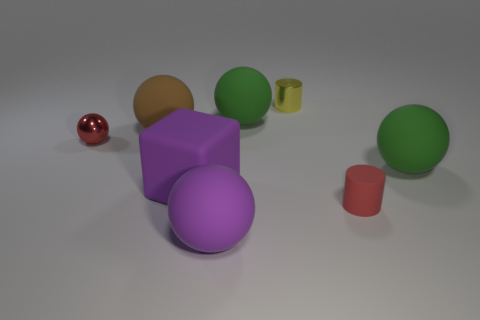Do the tiny red thing that is on the left side of the tiny matte cylinder and the metallic object behind the brown object have the same shape?
Offer a terse response. No. What shape is the red rubber object that is the same size as the yellow metallic object?
Provide a short and direct response. Cylinder. Is the number of large matte blocks that are on the left side of the red sphere the same as the number of tiny objects behind the red rubber cylinder?
Provide a succinct answer. No. Is the green ball to the left of the yellow object made of the same material as the yellow thing?
Offer a very short reply. No. What is the material of the sphere that is the same size as the shiny cylinder?
Give a very brief answer. Metal. How many other objects are the same material as the yellow thing?
Give a very brief answer. 1. There is a red cylinder; does it have the same size as the purple object to the right of the cube?
Your answer should be very brief. No. Are there fewer shiny objects that are in front of the small yellow metal object than rubber spheres behind the red cylinder?
Provide a succinct answer. Yes. There is a green matte thing that is behind the big brown ball; how big is it?
Your answer should be compact. Large. Do the brown rubber ball and the purple matte block have the same size?
Ensure brevity in your answer.  Yes. 